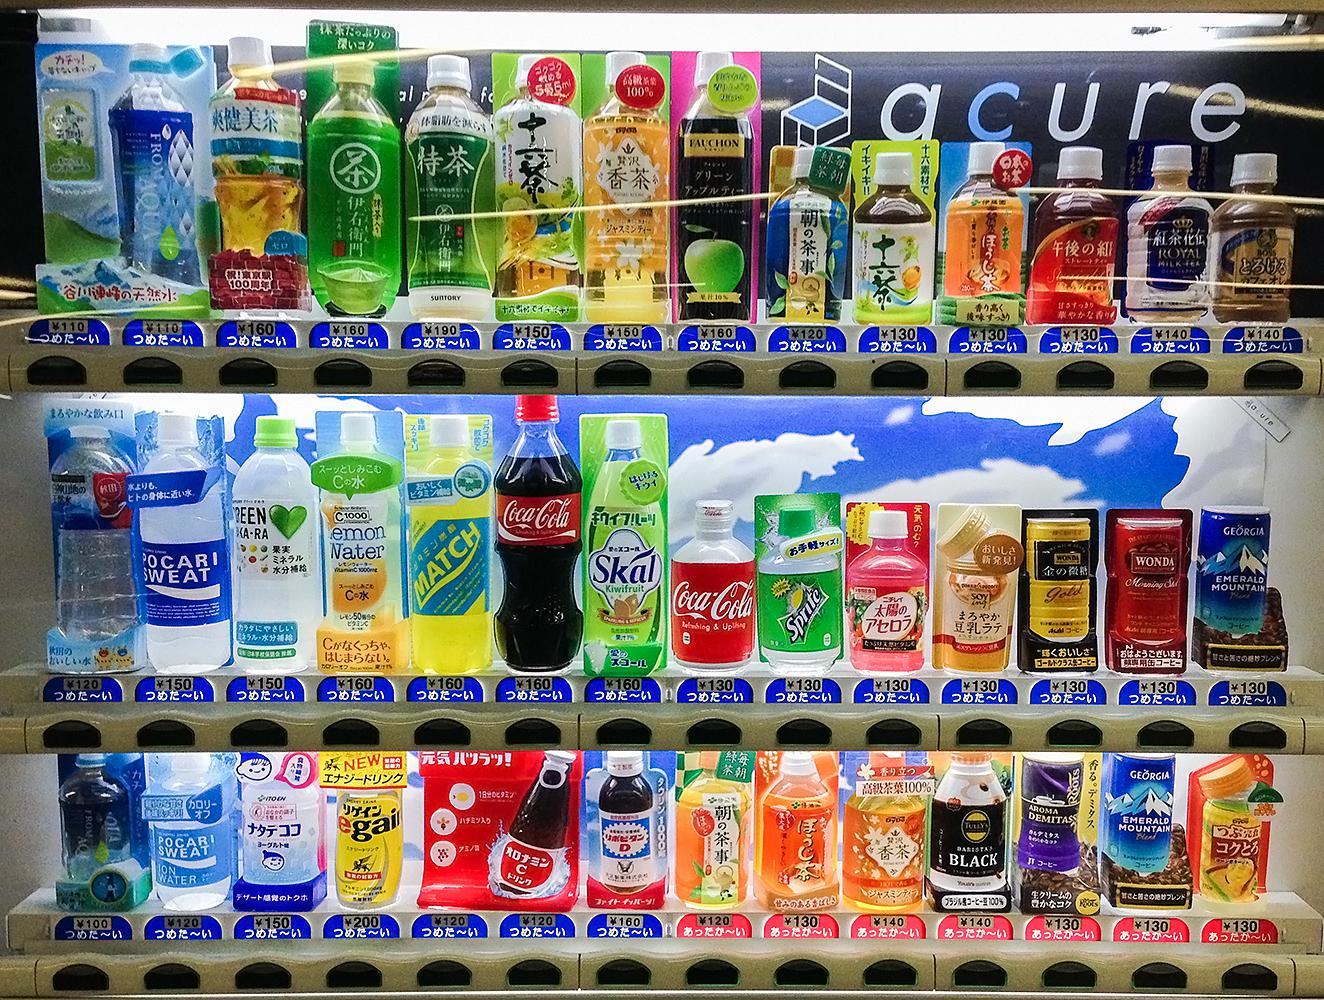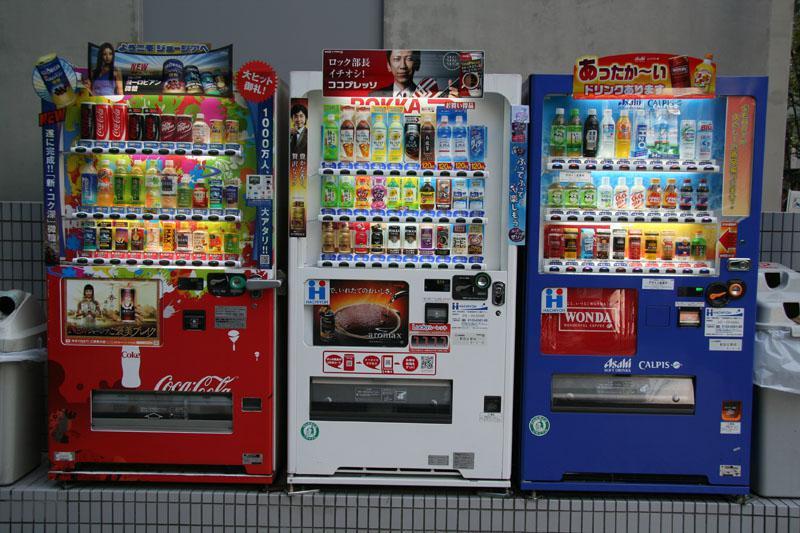The first image is the image on the left, the second image is the image on the right. Examine the images to the left and right. Is the description "Two trashcans are visible beside the vending machine in the image on the left." accurate? Answer yes or no. No. 